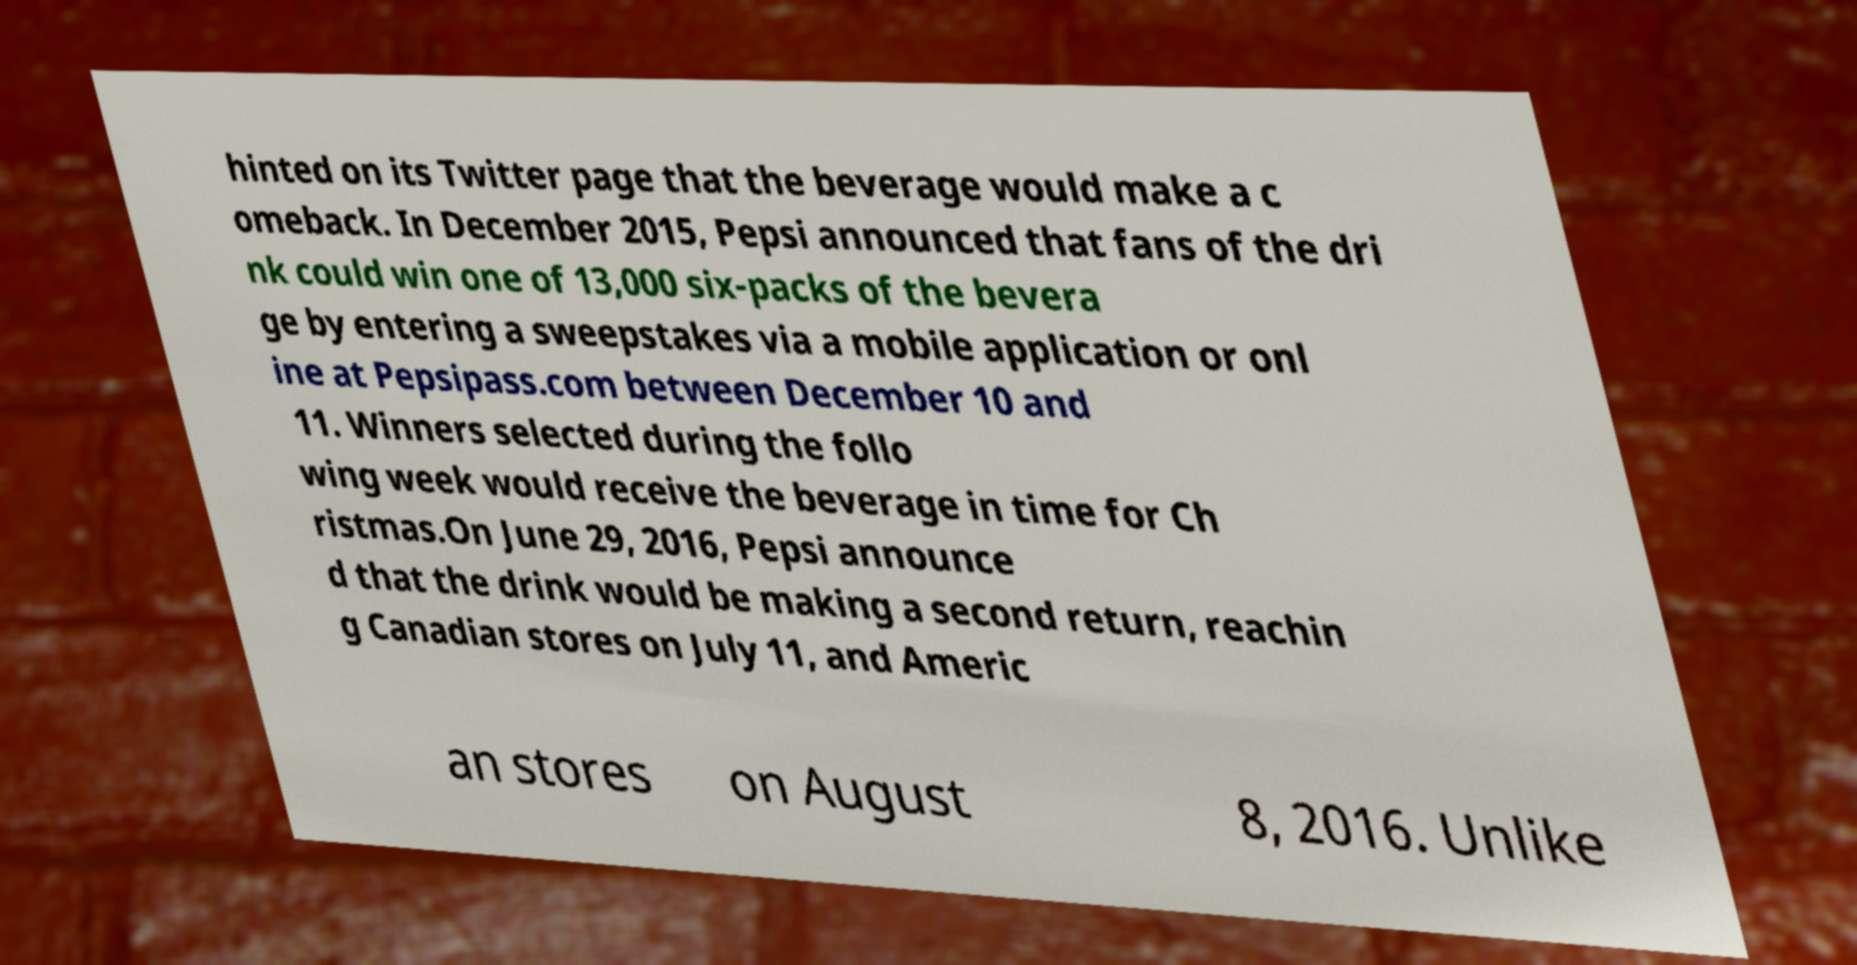Please identify and transcribe the text found in this image. hinted on its Twitter page that the beverage would make a c omeback. In December 2015, Pepsi announced that fans of the dri nk could win one of 13,000 six-packs of the bevera ge by entering a sweepstakes via a mobile application or onl ine at Pepsipass.com between December 10 and 11. Winners selected during the follo wing week would receive the beverage in time for Ch ristmas.On June 29, 2016, Pepsi announce d that the drink would be making a second return, reachin g Canadian stores on July 11, and Americ an stores on August 8, 2016. Unlike 